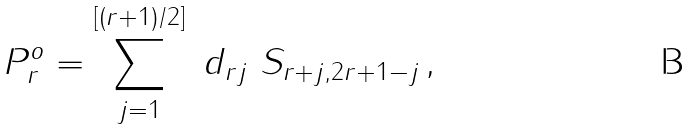<formula> <loc_0><loc_0><loc_500><loc_500>P _ { r } ^ { o } = \sum _ { j = 1 } ^ { [ ( r + 1 ) / 2 ] } \ d _ { r j } \ S _ { r + j , 2 r + 1 - j } \, ,</formula> 